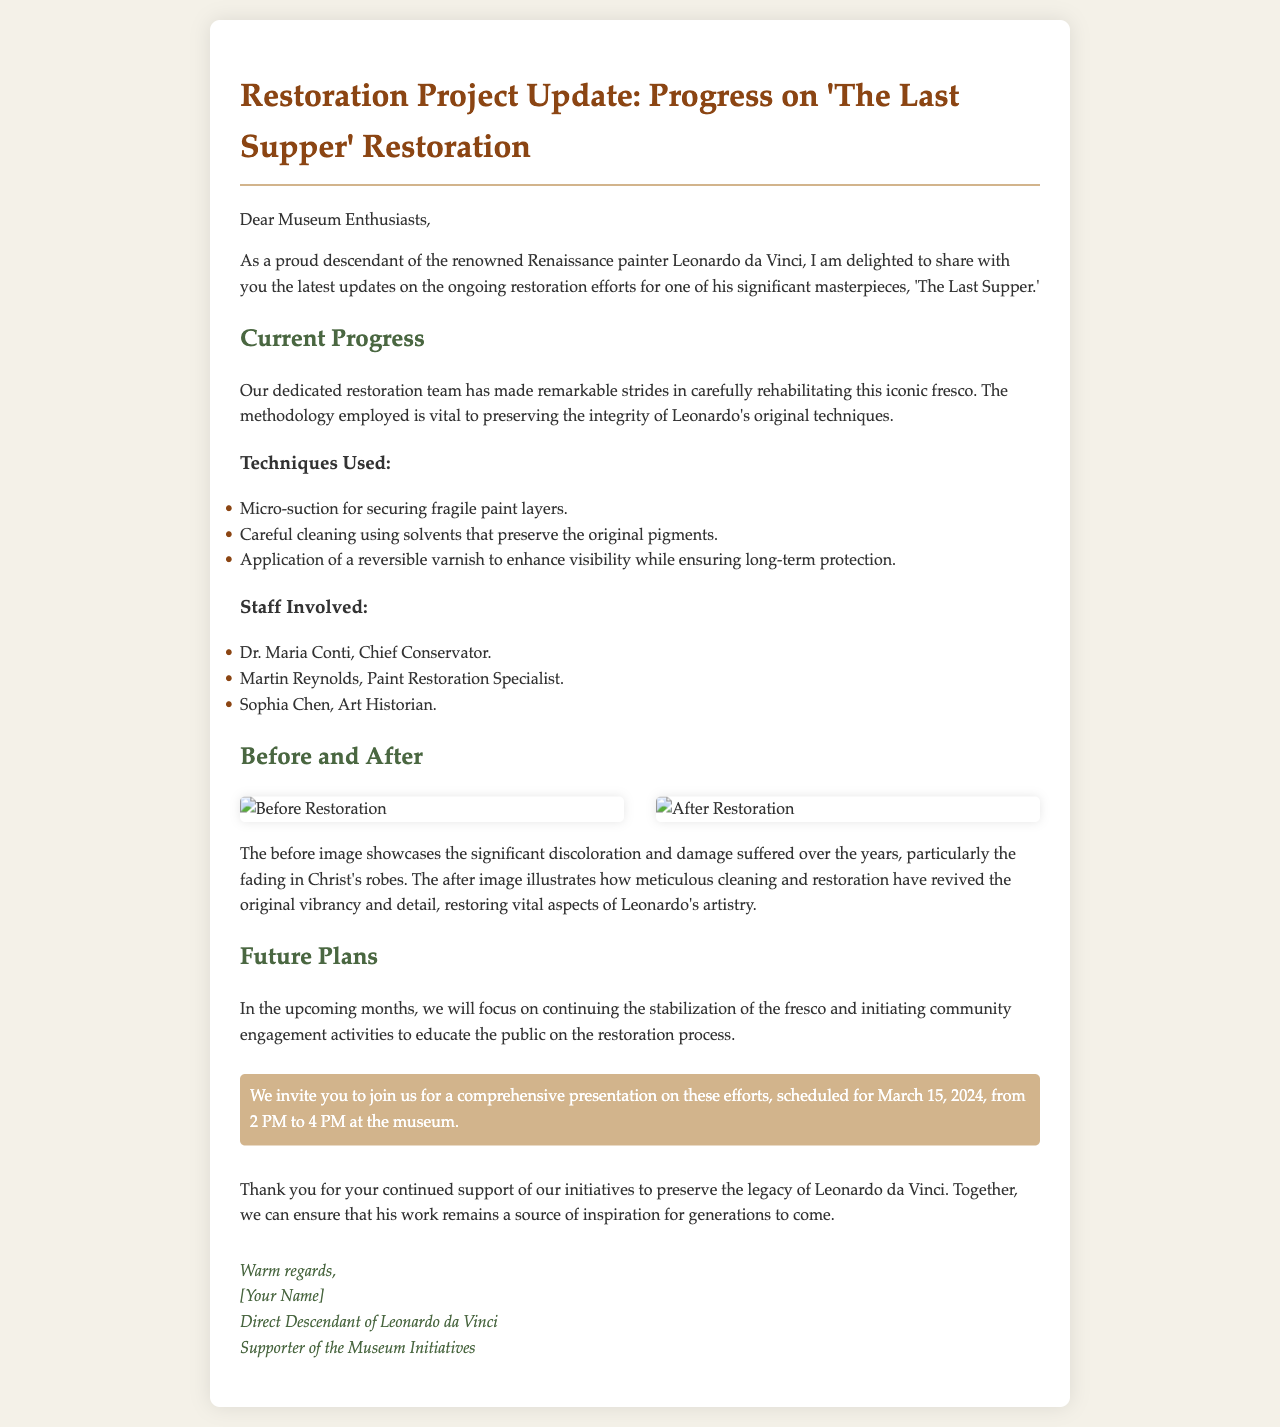What is the title of the restoration project? The title of the restoration project is specified in the email as "Restoration Project Update: Progress on 'The Last Supper' Restoration."
Answer: 'The Last Supper' Restoration Who is the Chief Conservator? The document lists Dr. Maria Conti as the Chief Conservator involved in the restoration efforts.
Answer: Dr. Maria Conti What techniques are used in the restoration? The email outlines specific techniques such as micro-suction, careful cleaning, and application of a reversible varnish for the restoration process.
Answer: Micro-suction, careful cleaning, reversible varnish When is the presentation scheduled? The event date provided in the email indicates that the comprehensive presentation is set for March 15, 2024.
Answer: March 15, 2024 How many staff members are involved in the restoration? The email lists three individuals as part of the restoration team, indicating the number of staff involved in the project.
Answer: Three What does the before image showcase? The text describes that the before image showcases significant discoloration and damage, particularly in Christ's robes.
Answer: Discoloration and damage What is the purpose of the community engagement activities? The email states that community engagement activities will be initiated to educate the public on the restoration process.
Answer: Educate the public What does the after image illustrate? The after image is described as illustrating how meticulous cleaning and restoration have revived the original vibrancy and detail.
Answer: Revived vibrancy and detail 